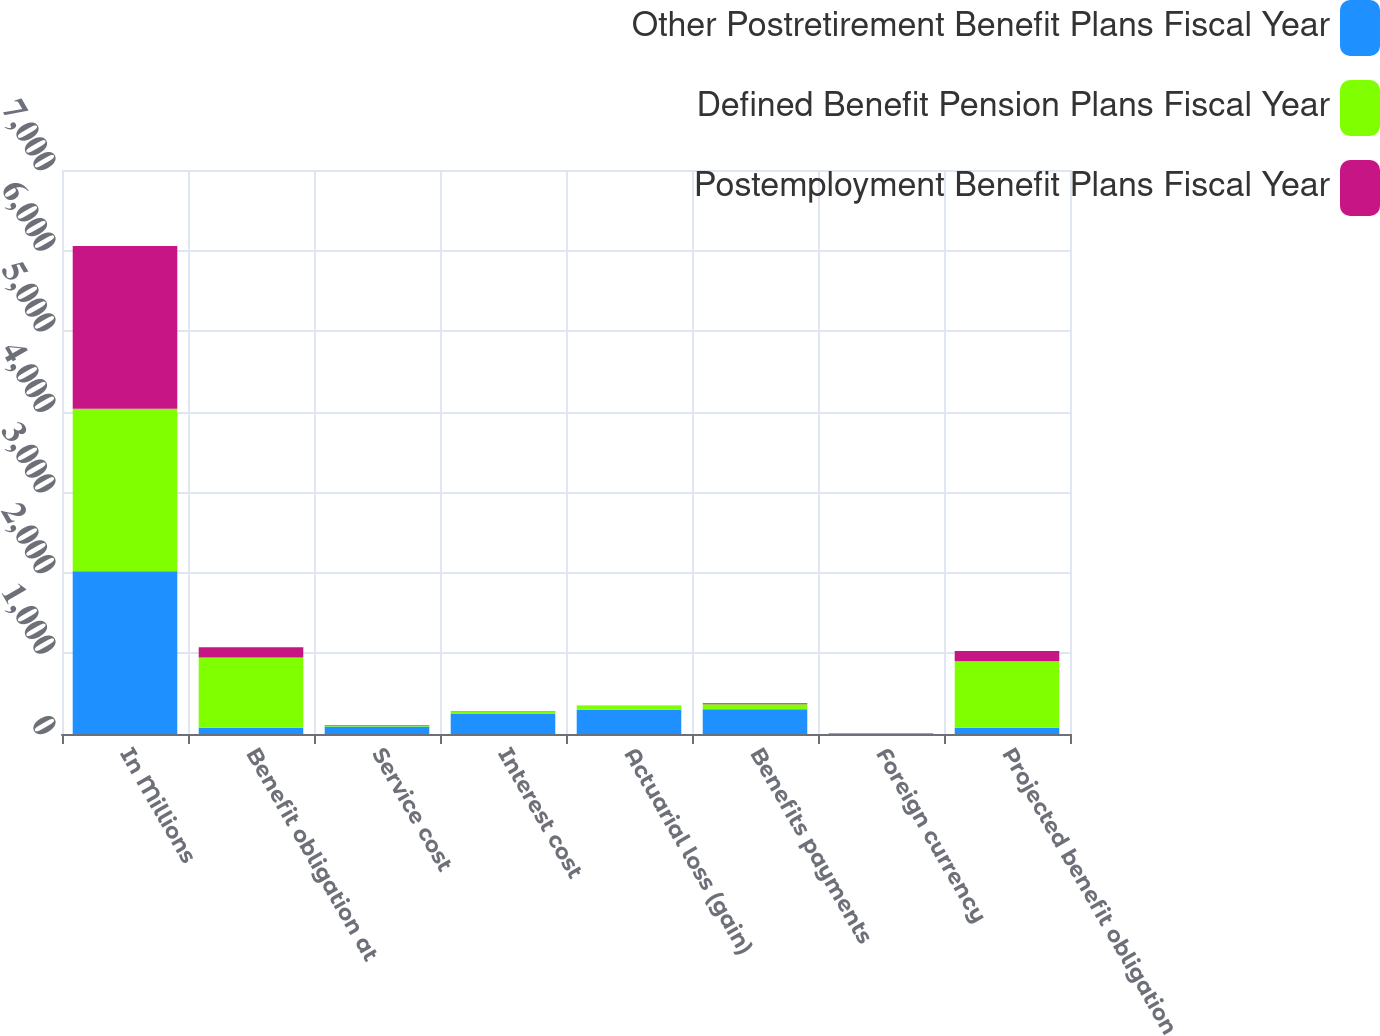Convert chart. <chart><loc_0><loc_0><loc_500><loc_500><stacked_bar_chart><ecel><fcel>In Millions<fcel>Benefit obligation at<fcel>Service cost<fcel>Interest cost<fcel>Actuarial loss (gain)<fcel>Benefits payments<fcel>Foreign currency<fcel>Projected benefit obligation<nl><fcel>Other Postretirement Benefit Plans Fiscal Year<fcel>2019<fcel>78.4<fcel>94.6<fcel>248<fcel>301.8<fcel>305.8<fcel>7.1<fcel>78.4<nl><fcel>Defined Benefit Pension Plans Fiscal Year<fcel>2019<fcel>871.8<fcel>9.9<fcel>33.1<fcel>45.4<fcel>62.2<fcel>0.6<fcel>824.1<nl><fcel>Postemployment Benefit Plans Fiscal Year<fcel>2019<fcel>126.7<fcel>7.6<fcel>3<fcel>2.6<fcel>13.2<fcel>0.4<fcel>128<nl></chart> 